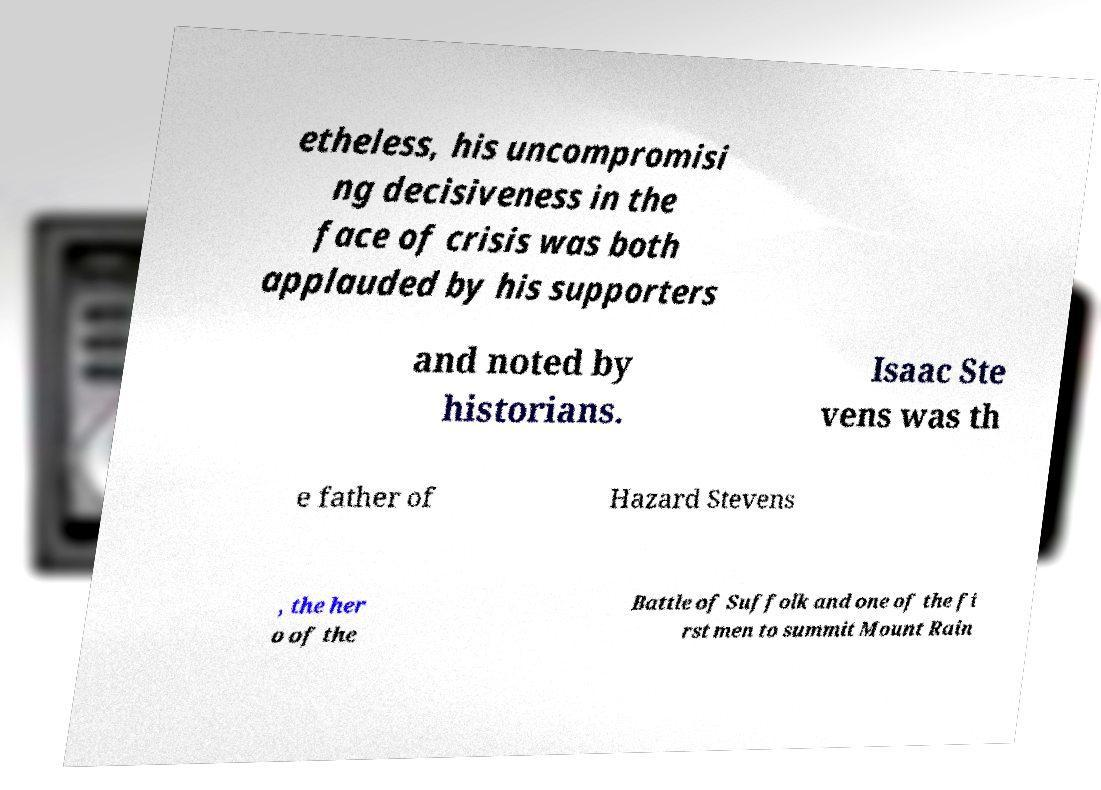Can you read and provide the text displayed in the image?This photo seems to have some interesting text. Can you extract and type it out for me? etheless, his uncompromisi ng decisiveness in the face of crisis was both applauded by his supporters and noted by historians. Isaac Ste vens was th e father of Hazard Stevens , the her o of the Battle of Suffolk and one of the fi rst men to summit Mount Rain 